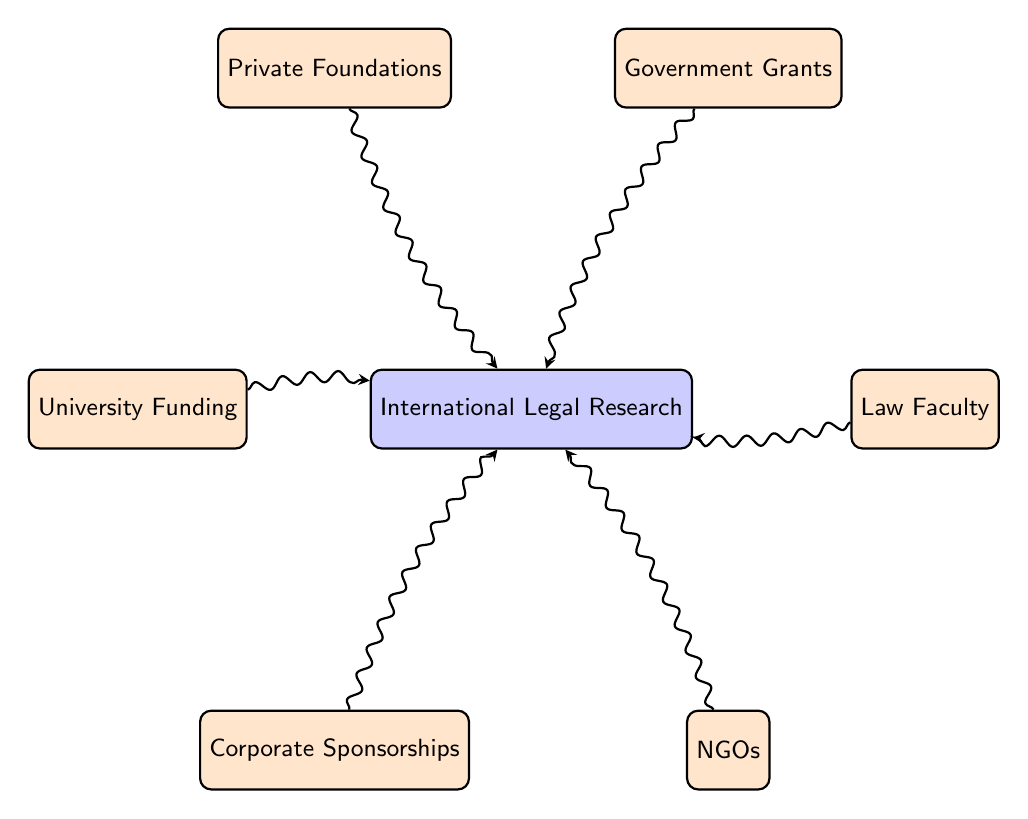What is the total number of nodes in the diagram? The diagram includes the following nodes: Law Faculty, International Legal Research, Government Grants, Private Foundations, University Funding, Corporate Sponsorships, and NGOs, amounting to a total of 6 nodes.
Answer: 6 How many funding sources are linked to International Legal Research? The diagram shows six sources linked to International Legal Research: Government Grants, Private Foundations, University Funding, Corporate Sponsorships, and NGOs. Therefore, there are 5 funding sources.
Answer: 5 Which node does Corporate Sponsorships connect to? By examining the diagram, Corporate Sponsorships has a directed connection leading to the International Legal Research node.
Answer: International Legal Research What type of funding does University Funding represent? In the context of the diagram, University Funding is identified as one of the sources contributing to International Legal Research. Therefore, it represents university-based funding.
Answer: University-based funding Is there any funding source that does not connect to International Legal Research? All nodes labeled as funding sources (Government Grants, Private Foundations, University Funding, Corporate Sponsorships, and NGOs) directly connect to International Legal Research, indicating no funding source is unconnected.
Answer: No How many connections are there from the funding sources to International Legal Research? Each funding source has a unique link to International Legal Research, totaling 5 connections as it includes all sources directly linked to it.
Answer: 5 Which funding source is closest to the Law Faculty in the diagram? In the arrangement of the nodes, Law Faculty connects directly with International Legal Research, making it the closest source in the diagram.
Answer: International Legal Research What does the thickness of the arrows represent in the context of the diagram? The thickness of the arrows is uniform in this diagram, suggesting equal significance or equal value of the funding connections to International Legal Research.
Answer: Equal significance 